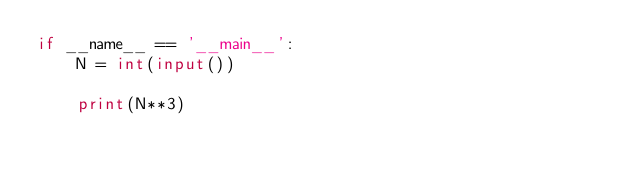Convert code to text. <code><loc_0><loc_0><loc_500><loc_500><_Python_>if __name__ == '__main__':
    N = int(input())
    
    print(N**3)
    </code> 